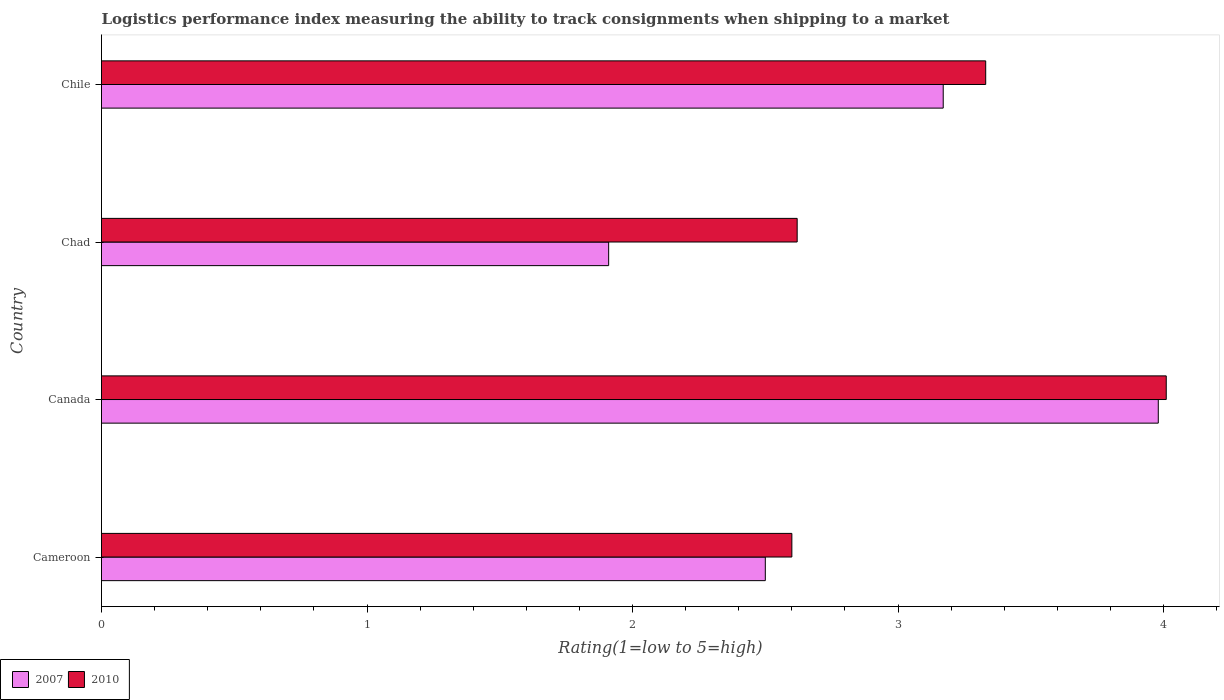How many bars are there on the 2nd tick from the top?
Ensure brevity in your answer.  2. What is the label of the 2nd group of bars from the top?
Keep it short and to the point. Chad. In how many cases, is the number of bars for a given country not equal to the number of legend labels?
Give a very brief answer. 0. What is the Logistic performance index in 2007 in Chad?
Your answer should be compact. 1.91. Across all countries, what is the maximum Logistic performance index in 2010?
Provide a succinct answer. 4.01. In which country was the Logistic performance index in 2007 minimum?
Your response must be concise. Chad. What is the total Logistic performance index in 2007 in the graph?
Provide a short and direct response. 11.56. What is the difference between the Logistic performance index in 2010 in Chad and that in Chile?
Give a very brief answer. -0.71. What is the difference between the Logistic performance index in 2007 in Chile and the Logistic performance index in 2010 in Cameroon?
Offer a terse response. 0.57. What is the average Logistic performance index in 2010 per country?
Make the answer very short. 3.14. What is the difference between the Logistic performance index in 2007 and Logistic performance index in 2010 in Cameroon?
Your answer should be very brief. -0.1. In how many countries, is the Logistic performance index in 2007 greater than 3.2 ?
Ensure brevity in your answer.  1. What is the ratio of the Logistic performance index in 2010 in Cameroon to that in Chile?
Offer a very short reply. 0.78. Is the difference between the Logistic performance index in 2007 in Cameroon and Chad greater than the difference between the Logistic performance index in 2010 in Cameroon and Chad?
Ensure brevity in your answer.  Yes. What is the difference between the highest and the second highest Logistic performance index in 2007?
Ensure brevity in your answer.  0.81. What is the difference between the highest and the lowest Logistic performance index in 2010?
Give a very brief answer. 1.41. In how many countries, is the Logistic performance index in 2010 greater than the average Logistic performance index in 2010 taken over all countries?
Provide a short and direct response. 2. Is the sum of the Logistic performance index in 2010 in Canada and Chile greater than the maximum Logistic performance index in 2007 across all countries?
Give a very brief answer. Yes. What does the 2nd bar from the bottom in Canada represents?
Ensure brevity in your answer.  2010. How many countries are there in the graph?
Provide a short and direct response. 4. Are the values on the major ticks of X-axis written in scientific E-notation?
Offer a very short reply. No. Does the graph contain any zero values?
Your response must be concise. No. Where does the legend appear in the graph?
Offer a terse response. Bottom left. How many legend labels are there?
Provide a short and direct response. 2. What is the title of the graph?
Make the answer very short. Logistics performance index measuring the ability to track consignments when shipping to a market. What is the label or title of the X-axis?
Ensure brevity in your answer.  Rating(1=low to 5=high). What is the Rating(1=low to 5=high) in 2007 in Cameroon?
Give a very brief answer. 2.5. What is the Rating(1=low to 5=high) of 2007 in Canada?
Give a very brief answer. 3.98. What is the Rating(1=low to 5=high) of 2010 in Canada?
Provide a short and direct response. 4.01. What is the Rating(1=low to 5=high) in 2007 in Chad?
Keep it short and to the point. 1.91. What is the Rating(1=low to 5=high) of 2010 in Chad?
Provide a succinct answer. 2.62. What is the Rating(1=low to 5=high) in 2007 in Chile?
Keep it short and to the point. 3.17. What is the Rating(1=low to 5=high) of 2010 in Chile?
Your response must be concise. 3.33. Across all countries, what is the maximum Rating(1=low to 5=high) in 2007?
Provide a short and direct response. 3.98. Across all countries, what is the maximum Rating(1=low to 5=high) in 2010?
Your answer should be compact. 4.01. Across all countries, what is the minimum Rating(1=low to 5=high) of 2007?
Give a very brief answer. 1.91. Across all countries, what is the minimum Rating(1=low to 5=high) of 2010?
Provide a short and direct response. 2.6. What is the total Rating(1=low to 5=high) of 2007 in the graph?
Give a very brief answer. 11.56. What is the total Rating(1=low to 5=high) in 2010 in the graph?
Provide a short and direct response. 12.56. What is the difference between the Rating(1=low to 5=high) of 2007 in Cameroon and that in Canada?
Offer a terse response. -1.48. What is the difference between the Rating(1=low to 5=high) in 2010 in Cameroon and that in Canada?
Your answer should be compact. -1.41. What is the difference between the Rating(1=low to 5=high) of 2007 in Cameroon and that in Chad?
Provide a short and direct response. 0.59. What is the difference between the Rating(1=low to 5=high) of 2010 in Cameroon and that in Chad?
Provide a short and direct response. -0.02. What is the difference between the Rating(1=low to 5=high) in 2007 in Cameroon and that in Chile?
Keep it short and to the point. -0.67. What is the difference between the Rating(1=low to 5=high) in 2010 in Cameroon and that in Chile?
Offer a terse response. -0.73. What is the difference between the Rating(1=low to 5=high) of 2007 in Canada and that in Chad?
Offer a very short reply. 2.07. What is the difference between the Rating(1=low to 5=high) of 2010 in Canada and that in Chad?
Provide a short and direct response. 1.39. What is the difference between the Rating(1=low to 5=high) in 2007 in Canada and that in Chile?
Provide a short and direct response. 0.81. What is the difference between the Rating(1=low to 5=high) in 2010 in Canada and that in Chile?
Your answer should be compact. 0.68. What is the difference between the Rating(1=low to 5=high) of 2007 in Chad and that in Chile?
Offer a very short reply. -1.26. What is the difference between the Rating(1=low to 5=high) of 2010 in Chad and that in Chile?
Give a very brief answer. -0.71. What is the difference between the Rating(1=low to 5=high) in 2007 in Cameroon and the Rating(1=low to 5=high) in 2010 in Canada?
Make the answer very short. -1.51. What is the difference between the Rating(1=low to 5=high) of 2007 in Cameroon and the Rating(1=low to 5=high) of 2010 in Chad?
Give a very brief answer. -0.12. What is the difference between the Rating(1=low to 5=high) of 2007 in Cameroon and the Rating(1=low to 5=high) of 2010 in Chile?
Your answer should be very brief. -0.83. What is the difference between the Rating(1=low to 5=high) of 2007 in Canada and the Rating(1=low to 5=high) of 2010 in Chad?
Your answer should be very brief. 1.36. What is the difference between the Rating(1=low to 5=high) of 2007 in Canada and the Rating(1=low to 5=high) of 2010 in Chile?
Ensure brevity in your answer.  0.65. What is the difference between the Rating(1=low to 5=high) of 2007 in Chad and the Rating(1=low to 5=high) of 2010 in Chile?
Ensure brevity in your answer.  -1.42. What is the average Rating(1=low to 5=high) of 2007 per country?
Ensure brevity in your answer.  2.89. What is the average Rating(1=low to 5=high) of 2010 per country?
Give a very brief answer. 3.14. What is the difference between the Rating(1=low to 5=high) in 2007 and Rating(1=low to 5=high) in 2010 in Canada?
Provide a succinct answer. -0.03. What is the difference between the Rating(1=low to 5=high) in 2007 and Rating(1=low to 5=high) in 2010 in Chad?
Your answer should be very brief. -0.71. What is the difference between the Rating(1=low to 5=high) of 2007 and Rating(1=low to 5=high) of 2010 in Chile?
Offer a terse response. -0.16. What is the ratio of the Rating(1=low to 5=high) in 2007 in Cameroon to that in Canada?
Provide a short and direct response. 0.63. What is the ratio of the Rating(1=low to 5=high) of 2010 in Cameroon to that in Canada?
Ensure brevity in your answer.  0.65. What is the ratio of the Rating(1=low to 5=high) in 2007 in Cameroon to that in Chad?
Ensure brevity in your answer.  1.31. What is the ratio of the Rating(1=low to 5=high) of 2007 in Cameroon to that in Chile?
Your answer should be compact. 0.79. What is the ratio of the Rating(1=low to 5=high) in 2010 in Cameroon to that in Chile?
Keep it short and to the point. 0.78. What is the ratio of the Rating(1=low to 5=high) in 2007 in Canada to that in Chad?
Make the answer very short. 2.08. What is the ratio of the Rating(1=low to 5=high) of 2010 in Canada to that in Chad?
Make the answer very short. 1.53. What is the ratio of the Rating(1=low to 5=high) in 2007 in Canada to that in Chile?
Your response must be concise. 1.26. What is the ratio of the Rating(1=low to 5=high) of 2010 in Canada to that in Chile?
Ensure brevity in your answer.  1.2. What is the ratio of the Rating(1=low to 5=high) in 2007 in Chad to that in Chile?
Your answer should be compact. 0.6. What is the ratio of the Rating(1=low to 5=high) in 2010 in Chad to that in Chile?
Make the answer very short. 0.79. What is the difference between the highest and the second highest Rating(1=low to 5=high) of 2007?
Offer a terse response. 0.81. What is the difference between the highest and the second highest Rating(1=low to 5=high) in 2010?
Your response must be concise. 0.68. What is the difference between the highest and the lowest Rating(1=low to 5=high) of 2007?
Ensure brevity in your answer.  2.07. What is the difference between the highest and the lowest Rating(1=low to 5=high) in 2010?
Provide a short and direct response. 1.41. 